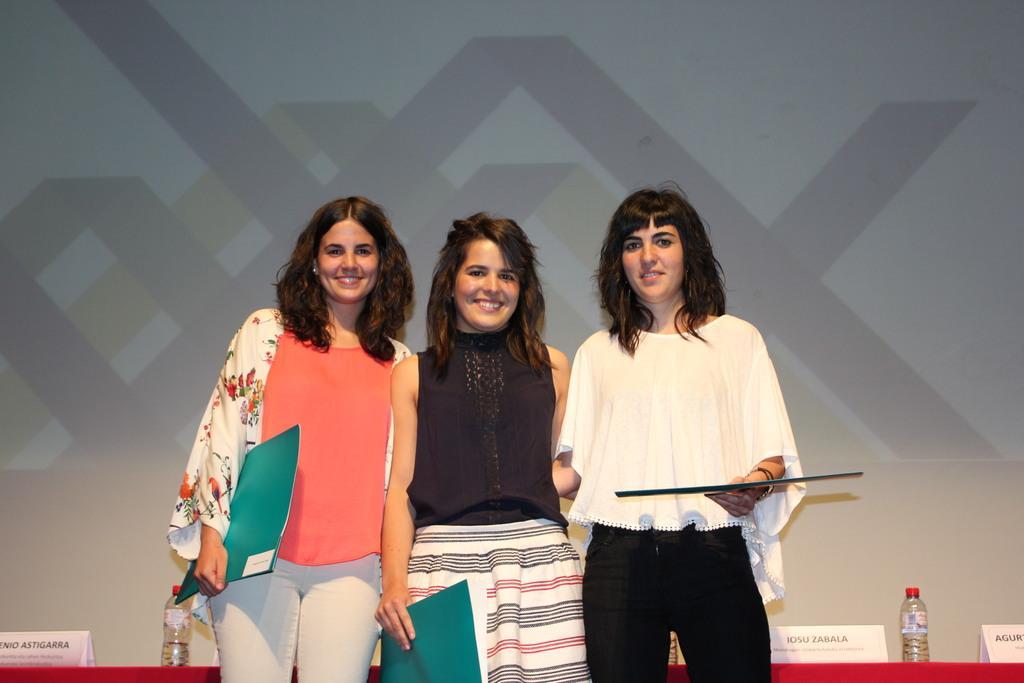Please provide a concise description of this image. In this image I can see three women wearing black, white and orange colored dresses are standing, smiling and holding few objects in their hands. In the background I can see a red colored object and on it I can see two bottles and few white colored boards. I can see some projection on the white colored surface. 